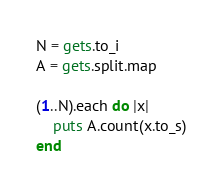<code> <loc_0><loc_0><loc_500><loc_500><_Ruby_>N = gets.to_i
A = gets.split.map

(1..N).each do |x|
    puts A.count(x.to_s)
end
</code> 